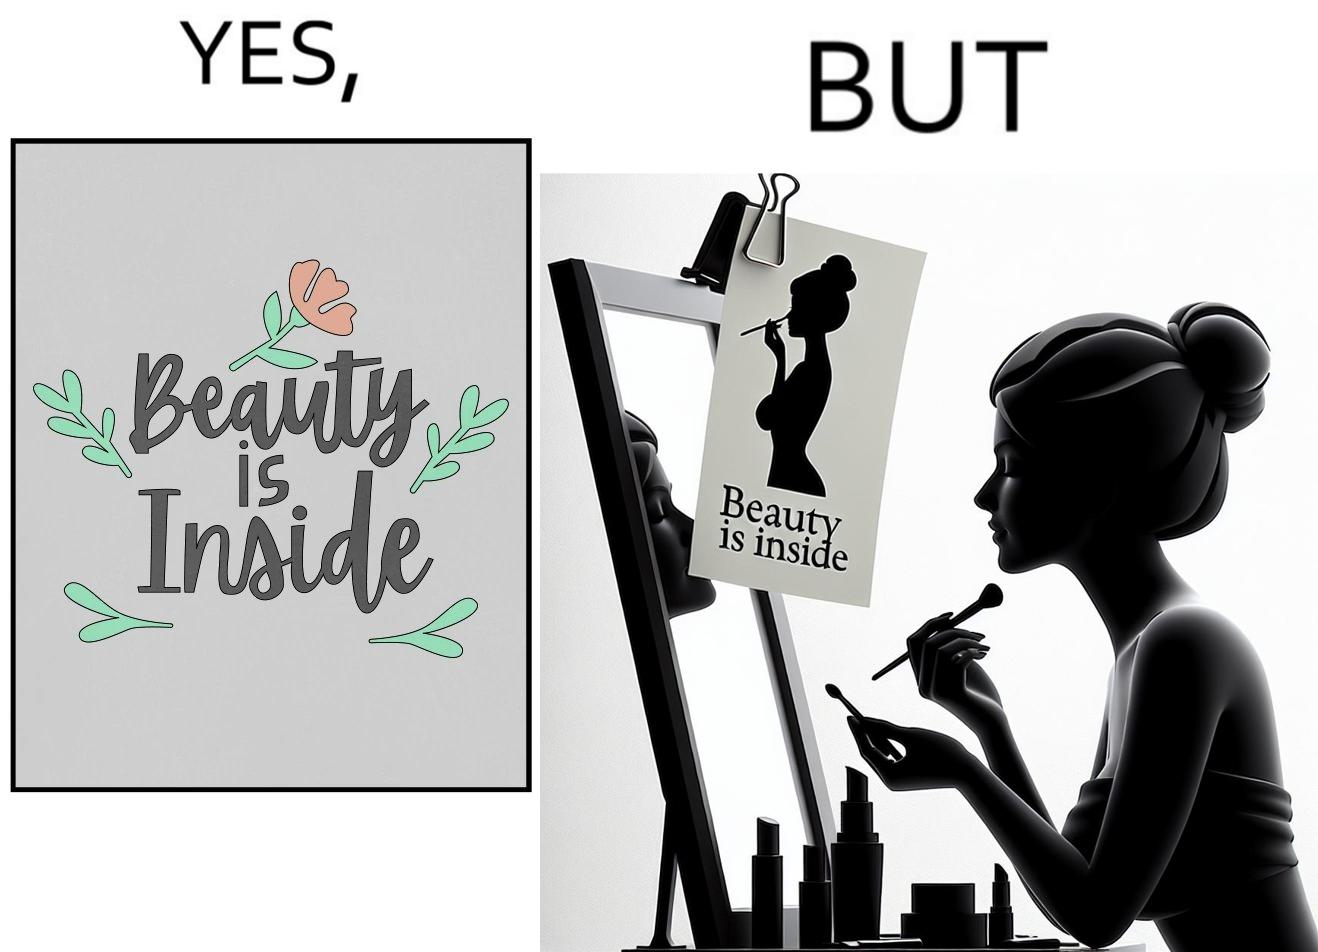Is there satirical content in this image? Yes, this image is satirical. 